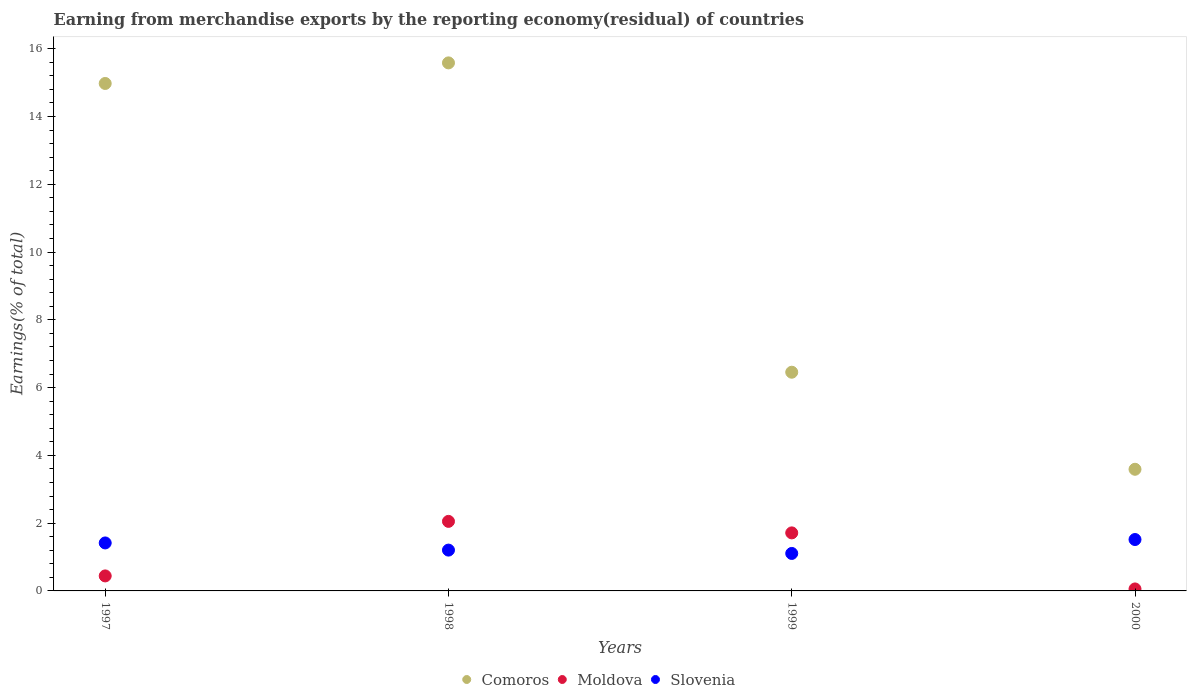How many different coloured dotlines are there?
Your answer should be compact. 3. What is the percentage of amount earned from merchandise exports in Moldova in 1997?
Make the answer very short. 0.44. Across all years, what is the maximum percentage of amount earned from merchandise exports in Slovenia?
Your answer should be very brief. 1.52. Across all years, what is the minimum percentage of amount earned from merchandise exports in Slovenia?
Your answer should be compact. 1.11. In which year was the percentage of amount earned from merchandise exports in Moldova maximum?
Offer a terse response. 1998. In which year was the percentage of amount earned from merchandise exports in Moldova minimum?
Your answer should be compact. 2000. What is the total percentage of amount earned from merchandise exports in Moldova in the graph?
Offer a very short reply. 4.27. What is the difference between the percentage of amount earned from merchandise exports in Slovenia in 1998 and that in 1999?
Offer a very short reply. 0.1. What is the difference between the percentage of amount earned from merchandise exports in Moldova in 1998 and the percentage of amount earned from merchandise exports in Comoros in 2000?
Provide a succinct answer. -1.54. What is the average percentage of amount earned from merchandise exports in Moldova per year?
Your answer should be very brief. 1.07. In the year 2000, what is the difference between the percentage of amount earned from merchandise exports in Moldova and percentage of amount earned from merchandise exports in Slovenia?
Give a very brief answer. -1.46. In how many years, is the percentage of amount earned from merchandise exports in Slovenia greater than 7.6 %?
Your response must be concise. 0. What is the ratio of the percentage of amount earned from merchandise exports in Comoros in 1997 to that in 2000?
Give a very brief answer. 4.17. Is the difference between the percentage of amount earned from merchandise exports in Moldova in 1997 and 1999 greater than the difference between the percentage of amount earned from merchandise exports in Slovenia in 1997 and 1999?
Your answer should be very brief. No. What is the difference between the highest and the second highest percentage of amount earned from merchandise exports in Slovenia?
Provide a short and direct response. 0.1. What is the difference between the highest and the lowest percentage of amount earned from merchandise exports in Comoros?
Ensure brevity in your answer.  11.99. In how many years, is the percentage of amount earned from merchandise exports in Comoros greater than the average percentage of amount earned from merchandise exports in Comoros taken over all years?
Provide a succinct answer. 2. Is the sum of the percentage of amount earned from merchandise exports in Moldova in 1998 and 2000 greater than the maximum percentage of amount earned from merchandise exports in Slovenia across all years?
Ensure brevity in your answer.  Yes. Is the percentage of amount earned from merchandise exports in Slovenia strictly greater than the percentage of amount earned from merchandise exports in Comoros over the years?
Make the answer very short. No. Is the percentage of amount earned from merchandise exports in Slovenia strictly less than the percentage of amount earned from merchandise exports in Moldova over the years?
Keep it short and to the point. No. How many years are there in the graph?
Provide a succinct answer. 4. What is the difference between two consecutive major ticks on the Y-axis?
Keep it short and to the point. 2. Does the graph contain grids?
Your answer should be very brief. No. Where does the legend appear in the graph?
Ensure brevity in your answer.  Bottom center. How many legend labels are there?
Provide a succinct answer. 3. How are the legend labels stacked?
Offer a very short reply. Horizontal. What is the title of the graph?
Give a very brief answer. Earning from merchandise exports by the reporting economy(residual) of countries. Does "Caribbean small states" appear as one of the legend labels in the graph?
Your answer should be compact. No. What is the label or title of the Y-axis?
Give a very brief answer. Earnings(% of total). What is the Earnings(% of total) in Comoros in 1997?
Your response must be concise. 14.98. What is the Earnings(% of total) in Moldova in 1997?
Offer a terse response. 0.44. What is the Earnings(% of total) of Slovenia in 1997?
Provide a short and direct response. 1.42. What is the Earnings(% of total) in Comoros in 1998?
Your answer should be very brief. 15.58. What is the Earnings(% of total) of Moldova in 1998?
Give a very brief answer. 2.05. What is the Earnings(% of total) in Slovenia in 1998?
Offer a terse response. 1.2. What is the Earnings(% of total) in Comoros in 1999?
Keep it short and to the point. 6.45. What is the Earnings(% of total) in Moldova in 1999?
Your response must be concise. 1.71. What is the Earnings(% of total) in Slovenia in 1999?
Provide a short and direct response. 1.11. What is the Earnings(% of total) in Comoros in 2000?
Your answer should be compact. 3.59. What is the Earnings(% of total) in Moldova in 2000?
Ensure brevity in your answer.  0.06. What is the Earnings(% of total) of Slovenia in 2000?
Your answer should be compact. 1.52. Across all years, what is the maximum Earnings(% of total) in Comoros?
Your answer should be very brief. 15.58. Across all years, what is the maximum Earnings(% of total) of Moldova?
Provide a short and direct response. 2.05. Across all years, what is the maximum Earnings(% of total) of Slovenia?
Make the answer very short. 1.52. Across all years, what is the minimum Earnings(% of total) in Comoros?
Offer a terse response. 3.59. Across all years, what is the minimum Earnings(% of total) of Moldova?
Provide a succinct answer. 0.06. Across all years, what is the minimum Earnings(% of total) in Slovenia?
Provide a succinct answer. 1.11. What is the total Earnings(% of total) in Comoros in the graph?
Keep it short and to the point. 40.6. What is the total Earnings(% of total) in Moldova in the graph?
Make the answer very short. 4.27. What is the total Earnings(% of total) in Slovenia in the graph?
Make the answer very short. 5.24. What is the difference between the Earnings(% of total) in Comoros in 1997 and that in 1998?
Offer a terse response. -0.61. What is the difference between the Earnings(% of total) of Moldova in 1997 and that in 1998?
Your response must be concise. -1.61. What is the difference between the Earnings(% of total) of Slovenia in 1997 and that in 1998?
Provide a short and direct response. 0.21. What is the difference between the Earnings(% of total) in Comoros in 1997 and that in 1999?
Offer a very short reply. 8.52. What is the difference between the Earnings(% of total) of Moldova in 1997 and that in 1999?
Your response must be concise. -1.27. What is the difference between the Earnings(% of total) in Slovenia in 1997 and that in 1999?
Ensure brevity in your answer.  0.31. What is the difference between the Earnings(% of total) in Comoros in 1997 and that in 2000?
Offer a very short reply. 11.39. What is the difference between the Earnings(% of total) in Moldova in 1997 and that in 2000?
Ensure brevity in your answer.  0.38. What is the difference between the Earnings(% of total) of Slovenia in 1997 and that in 2000?
Keep it short and to the point. -0.1. What is the difference between the Earnings(% of total) in Comoros in 1998 and that in 1999?
Your answer should be compact. 9.13. What is the difference between the Earnings(% of total) of Moldova in 1998 and that in 1999?
Your answer should be very brief. 0.34. What is the difference between the Earnings(% of total) of Slovenia in 1998 and that in 1999?
Your response must be concise. 0.1. What is the difference between the Earnings(% of total) of Comoros in 1998 and that in 2000?
Keep it short and to the point. 11.99. What is the difference between the Earnings(% of total) in Moldova in 1998 and that in 2000?
Keep it short and to the point. 1.99. What is the difference between the Earnings(% of total) of Slovenia in 1998 and that in 2000?
Make the answer very short. -0.31. What is the difference between the Earnings(% of total) of Comoros in 1999 and that in 2000?
Provide a short and direct response. 2.86. What is the difference between the Earnings(% of total) in Moldova in 1999 and that in 2000?
Provide a short and direct response. 1.65. What is the difference between the Earnings(% of total) in Slovenia in 1999 and that in 2000?
Give a very brief answer. -0.41. What is the difference between the Earnings(% of total) in Comoros in 1997 and the Earnings(% of total) in Moldova in 1998?
Provide a short and direct response. 12.92. What is the difference between the Earnings(% of total) of Comoros in 1997 and the Earnings(% of total) of Slovenia in 1998?
Offer a terse response. 13.77. What is the difference between the Earnings(% of total) of Moldova in 1997 and the Earnings(% of total) of Slovenia in 1998?
Give a very brief answer. -0.76. What is the difference between the Earnings(% of total) of Comoros in 1997 and the Earnings(% of total) of Moldova in 1999?
Provide a short and direct response. 13.26. What is the difference between the Earnings(% of total) in Comoros in 1997 and the Earnings(% of total) in Slovenia in 1999?
Offer a very short reply. 13.87. What is the difference between the Earnings(% of total) in Moldova in 1997 and the Earnings(% of total) in Slovenia in 1999?
Keep it short and to the point. -0.66. What is the difference between the Earnings(% of total) in Comoros in 1997 and the Earnings(% of total) in Moldova in 2000?
Make the answer very short. 14.92. What is the difference between the Earnings(% of total) of Comoros in 1997 and the Earnings(% of total) of Slovenia in 2000?
Make the answer very short. 13.46. What is the difference between the Earnings(% of total) of Moldova in 1997 and the Earnings(% of total) of Slovenia in 2000?
Offer a very short reply. -1.07. What is the difference between the Earnings(% of total) of Comoros in 1998 and the Earnings(% of total) of Moldova in 1999?
Your answer should be very brief. 13.87. What is the difference between the Earnings(% of total) of Comoros in 1998 and the Earnings(% of total) of Slovenia in 1999?
Your answer should be compact. 14.48. What is the difference between the Earnings(% of total) in Moldova in 1998 and the Earnings(% of total) in Slovenia in 1999?
Keep it short and to the point. 0.95. What is the difference between the Earnings(% of total) of Comoros in 1998 and the Earnings(% of total) of Moldova in 2000?
Give a very brief answer. 15.52. What is the difference between the Earnings(% of total) of Comoros in 1998 and the Earnings(% of total) of Slovenia in 2000?
Give a very brief answer. 14.07. What is the difference between the Earnings(% of total) in Moldova in 1998 and the Earnings(% of total) in Slovenia in 2000?
Provide a short and direct response. 0.54. What is the difference between the Earnings(% of total) in Comoros in 1999 and the Earnings(% of total) in Moldova in 2000?
Your answer should be very brief. 6.4. What is the difference between the Earnings(% of total) in Comoros in 1999 and the Earnings(% of total) in Slovenia in 2000?
Offer a very short reply. 4.94. What is the difference between the Earnings(% of total) of Moldova in 1999 and the Earnings(% of total) of Slovenia in 2000?
Your answer should be compact. 0.2. What is the average Earnings(% of total) in Comoros per year?
Provide a short and direct response. 10.15. What is the average Earnings(% of total) of Moldova per year?
Keep it short and to the point. 1.07. What is the average Earnings(% of total) of Slovenia per year?
Offer a very short reply. 1.31. In the year 1997, what is the difference between the Earnings(% of total) in Comoros and Earnings(% of total) in Moldova?
Provide a short and direct response. 14.53. In the year 1997, what is the difference between the Earnings(% of total) of Comoros and Earnings(% of total) of Slovenia?
Make the answer very short. 13.56. In the year 1997, what is the difference between the Earnings(% of total) in Moldova and Earnings(% of total) in Slovenia?
Provide a short and direct response. -0.97. In the year 1998, what is the difference between the Earnings(% of total) of Comoros and Earnings(% of total) of Moldova?
Ensure brevity in your answer.  13.53. In the year 1998, what is the difference between the Earnings(% of total) in Comoros and Earnings(% of total) in Slovenia?
Offer a terse response. 14.38. In the year 1998, what is the difference between the Earnings(% of total) of Moldova and Earnings(% of total) of Slovenia?
Provide a succinct answer. 0.85. In the year 1999, what is the difference between the Earnings(% of total) in Comoros and Earnings(% of total) in Moldova?
Keep it short and to the point. 4.74. In the year 1999, what is the difference between the Earnings(% of total) of Comoros and Earnings(% of total) of Slovenia?
Ensure brevity in your answer.  5.35. In the year 1999, what is the difference between the Earnings(% of total) in Moldova and Earnings(% of total) in Slovenia?
Give a very brief answer. 0.61. In the year 2000, what is the difference between the Earnings(% of total) in Comoros and Earnings(% of total) in Moldova?
Make the answer very short. 3.53. In the year 2000, what is the difference between the Earnings(% of total) of Comoros and Earnings(% of total) of Slovenia?
Provide a succinct answer. 2.07. In the year 2000, what is the difference between the Earnings(% of total) of Moldova and Earnings(% of total) of Slovenia?
Ensure brevity in your answer.  -1.46. What is the ratio of the Earnings(% of total) in Moldova in 1997 to that in 1998?
Your answer should be very brief. 0.22. What is the ratio of the Earnings(% of total) in Slovenia in 1997 to that in 1998?
Offer a very short reply. 1.18. What is the ratio of the Earnings(% of total) of Comoros in 1997 to that in 1999?
Keep it short and to the point. 2.32. What is the ratio of the Earnings(% of total) in Moldova in 1997 to that in 1999?
Your answer should be very brief. 0.26. What is the ratio of the Earnings(% of total) of Slovenia in 1997 to that in 1999?
Offer a terse response. 1.28. What is the ratio of the Earnings(% of total) in Comoros in 1997 to that in 2000?
Offer a terse response. 4.17. What is the ratio of the Earnings(% of total) in Moldova in 1997 to that in 2000?
Make the answer very short. 7.61. What is the ratio of the Earnings(% of total) in Slovenia in 1997 to that in 2000?
Offer a terse response. 0.93. What is the ratio of the Earnings(% of total) in Comoros in 1998 to that in 1999?
Offer a terse response. 2.41. What is the ratio of the Earnings(% of total) in Moldova in 1998 to that in 1999?
Offer a terse response. 1.2. What is the ratio of the Earnings(% of total) of Slovenia in 1998 to that in 1999?
Your response must be concise. 1.09. What is the ratio of the Earnings(% of total) in Comoros in 1998 to that in 2000?
Offer a very short reply. 4.34. What is the ratio of the Earnings(% of total) in Moldova in 1998 to that in 2000?
Give a very brief answer. 35.26. What is the ratio of the Earnings(% of total) in Slovenia in 1998 to that in 2000?
Provide a short and direct response. 0.79. What is the ratio of the Earnings(% of total) in Comoros in 1999 to that in 2000?
Your response must be concise. 1.8. What is the ratio of the Earnings(% of total) of Moldova in 1999 to that in 2000?
Provide a short and direct response. 29.42. What is the ratio of the Earnings(% of total) of Slovenia in 1999 to that in 2000?
Ensure brevity in your answer.  0.73. What is the difference between the highest and the second highest Earnings(% of total) in Comoros?
Your response must be concise. 0.61. What is the difference between the highest and the second highest Earnings(% of total) in Moldova?
Ensure brevity in your answer.  0.34. What is the difference between the highest and the second highest Earnings(% of total) of Slovenia?
Provide a short and direct response. 0.1. What is the difference between the highest and the lowest Earnings(% of total) in Comoros?
Your response must be concise. 11.99. What is the difference between the highest and the lowest Earnings(% of total) in Moldova?
Give a very brief answer. 1.99. What is the difference between the highest and the lowest Earnings(% of total) of Slovenia?
Offer a very short reply. 0.41. 